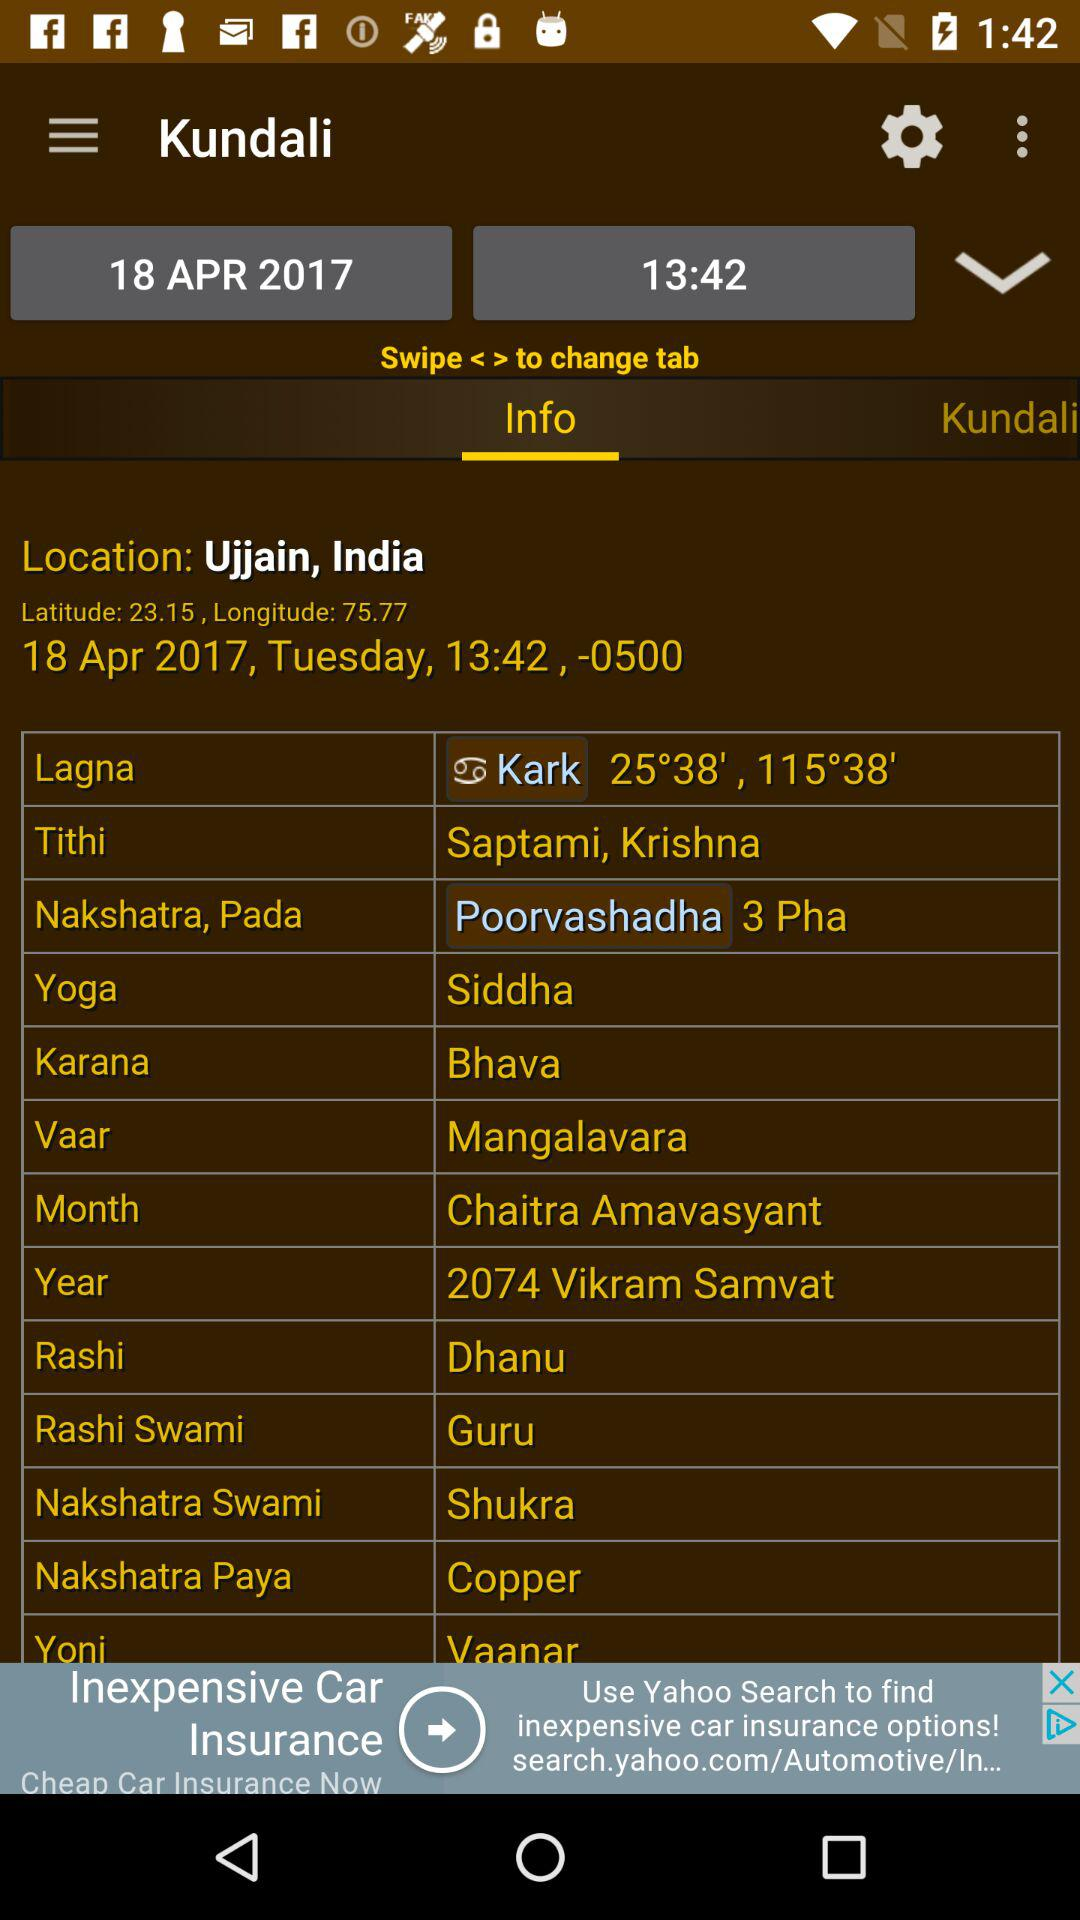What is the location? The location is Ujjain, India. 